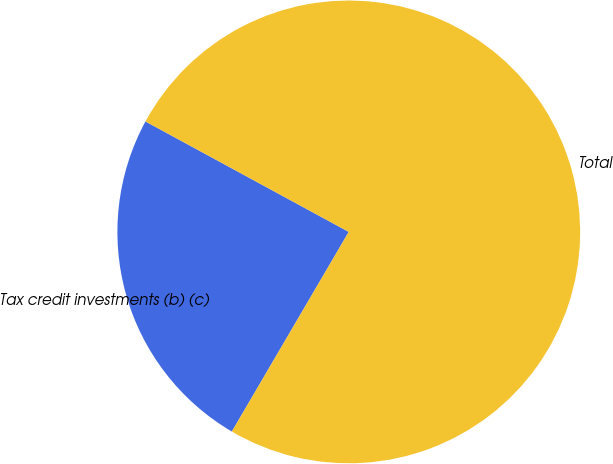<chart> <loc_0><loc_0><loc_500><loc_500><pie_chart><fcel>Tax credit investments (b) (c)<fcel>Total<nl><fcel>24.49%<fcel>75.51%<nl></chart> 